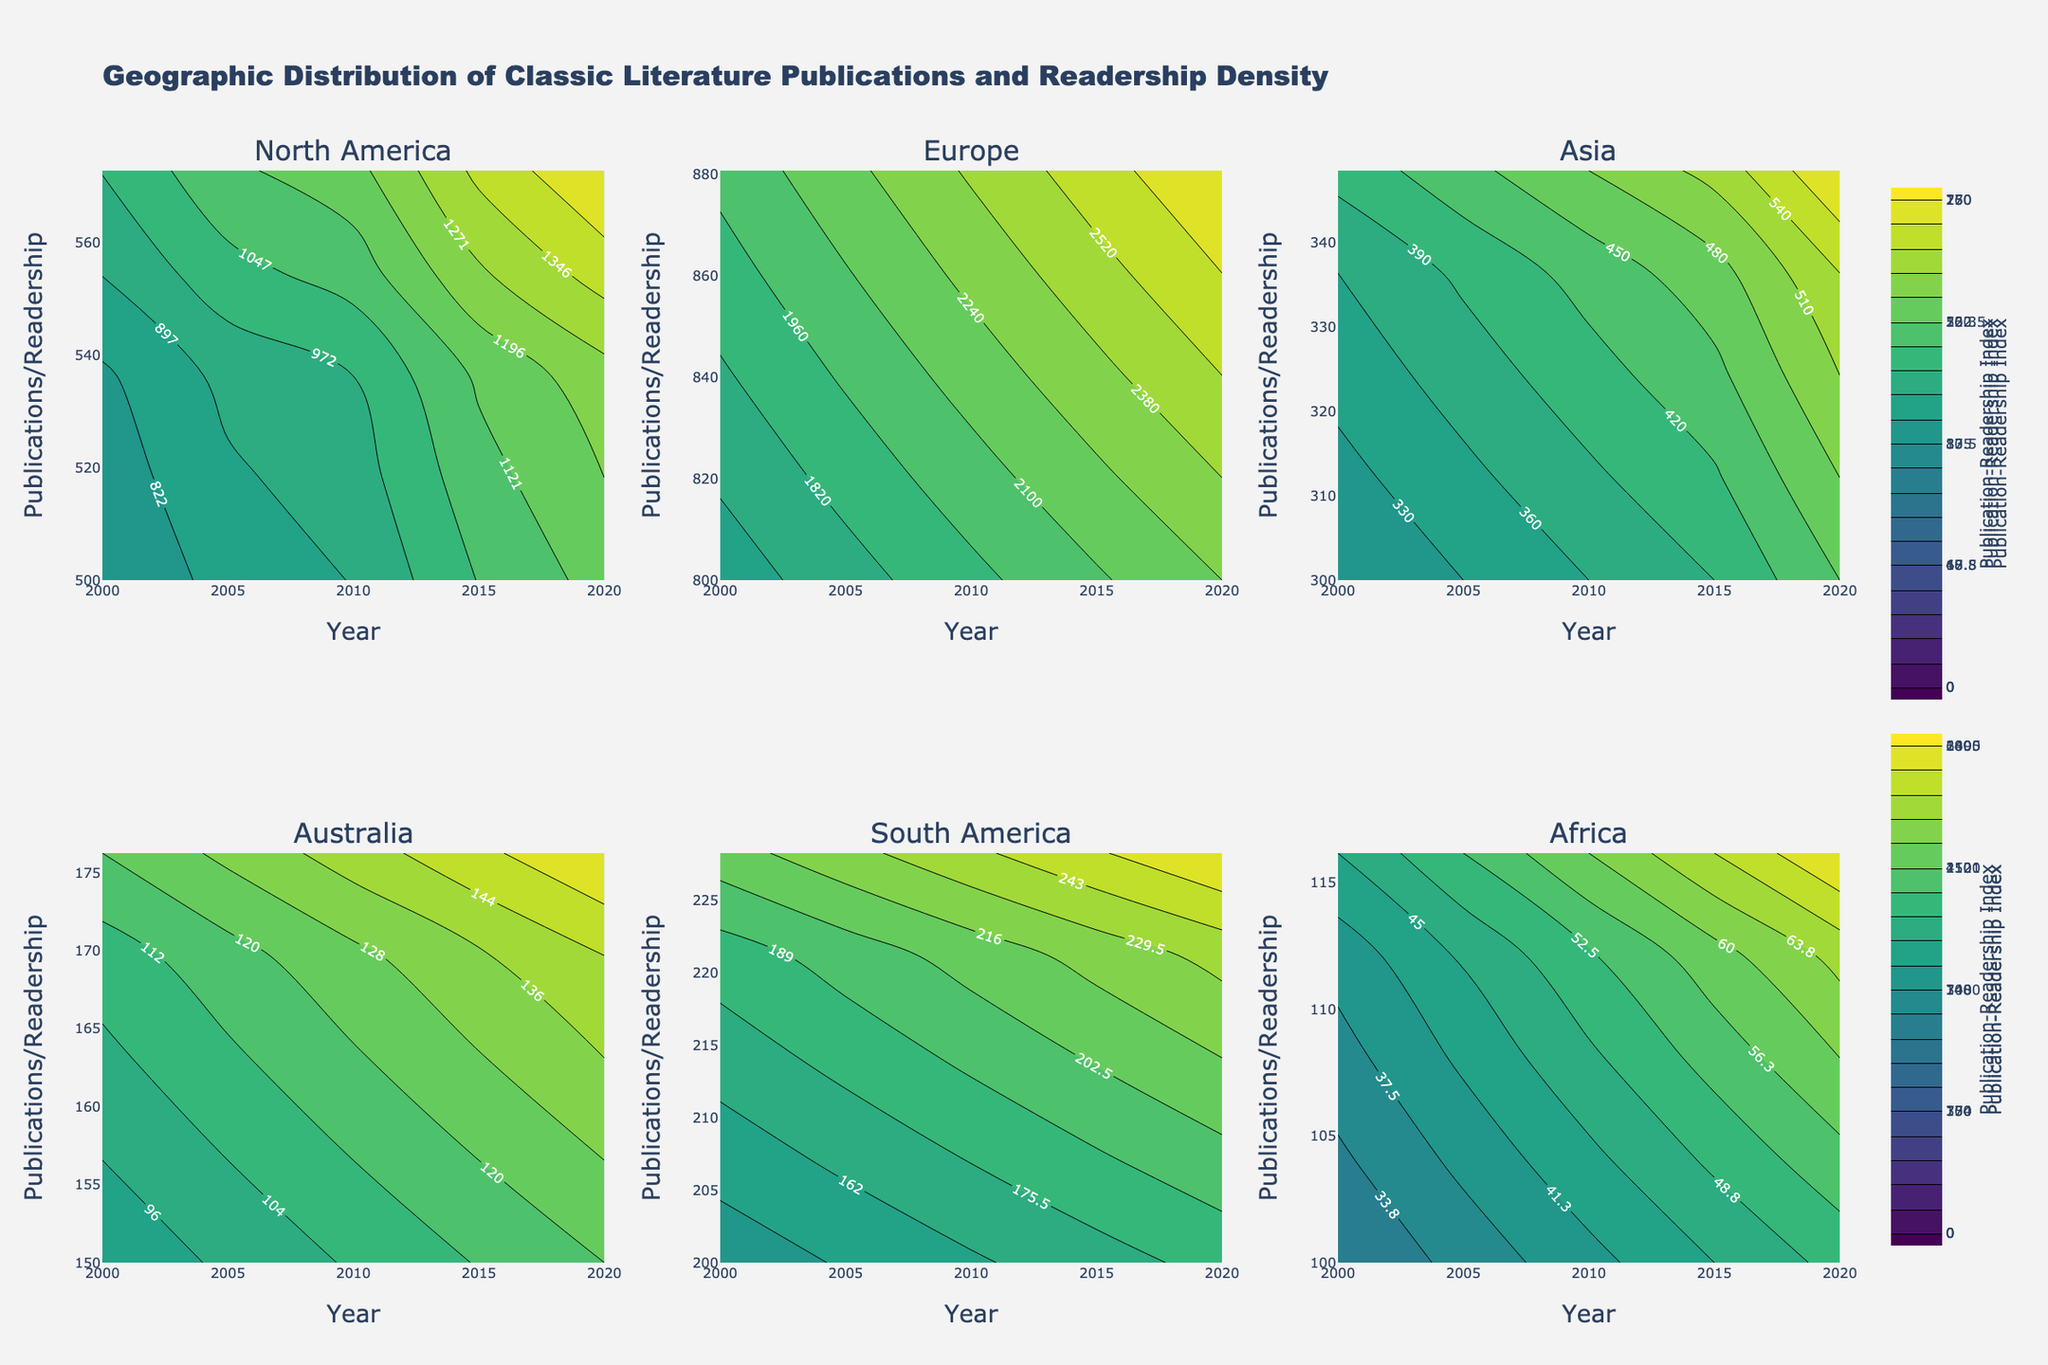What is the title of the figure? The title of the figure is usually located at the top center and describes the main theme or subject of the visual. Here, it is written clearly at the top.
Answer: Geographic Distribution of Classic Literature Publications and Readership Density How many subplots are present in the figure? By observing the division, you can see the figure is divided into multiple smaller plots. Each of these smaller plots is a subplot. Counting them gives the total number.
Answer: 6 Which region shows the highest Publication-Readership Index in 2020? The Publication-Readership Index can be inferred from darker/shaded areas within the contours. By locating the 2020 line for each region, check for the highest contour level.
Answer: Europe What is the general trend in the readership density in North America from 2000 to 2020? Look at the direction of the contour lines in North America's subplot. If trend lines go upward as they move from 2000 to 2020, it indicates an increase.
Answer: Increasing Between which years did Europe see the most significant increase in publications? Check the contour lines in Europe’s subplot. The steepest vertical rise in lines corresponds to the years between which the increase happened.
Answer: 2015 to 2020 Is there a region where the number of publications changed very little from 2000 to 2020? Examine the contour plots to identify a region with almost horizontal lines across the years. Horizontal lines indicate a minimal change in publications.
Answer: Australia Which region shows the lowest readership density throughout the period? Compare the lowest contour level for readership density across all regions. The region with the lowest overall contour levels indicates the lowest readership density.
Answer: Africa Comparing Asia and South America, which one has a more consistent increase in publications? Consistent increase implies a steady upward trend. Compare the contour plots of Asia and South America; the one with more regularly spaced vertical lines indicates consistency.
Answer: South America Is there any region where the publication-readership index decreases after 2010? By observing the contour lines' movement post-2010, if a region has lines descending, it indicates a decrease in the index. Identify such a region through this pattern.
Answer: No region What do the color scales represent in the figure? The color scale, often present as a gradient bar next to the plot, provides a visual measure. It is used to denote the intensity of the contour, which correlates with the value represented.
Answer: Publication-Readership Index 